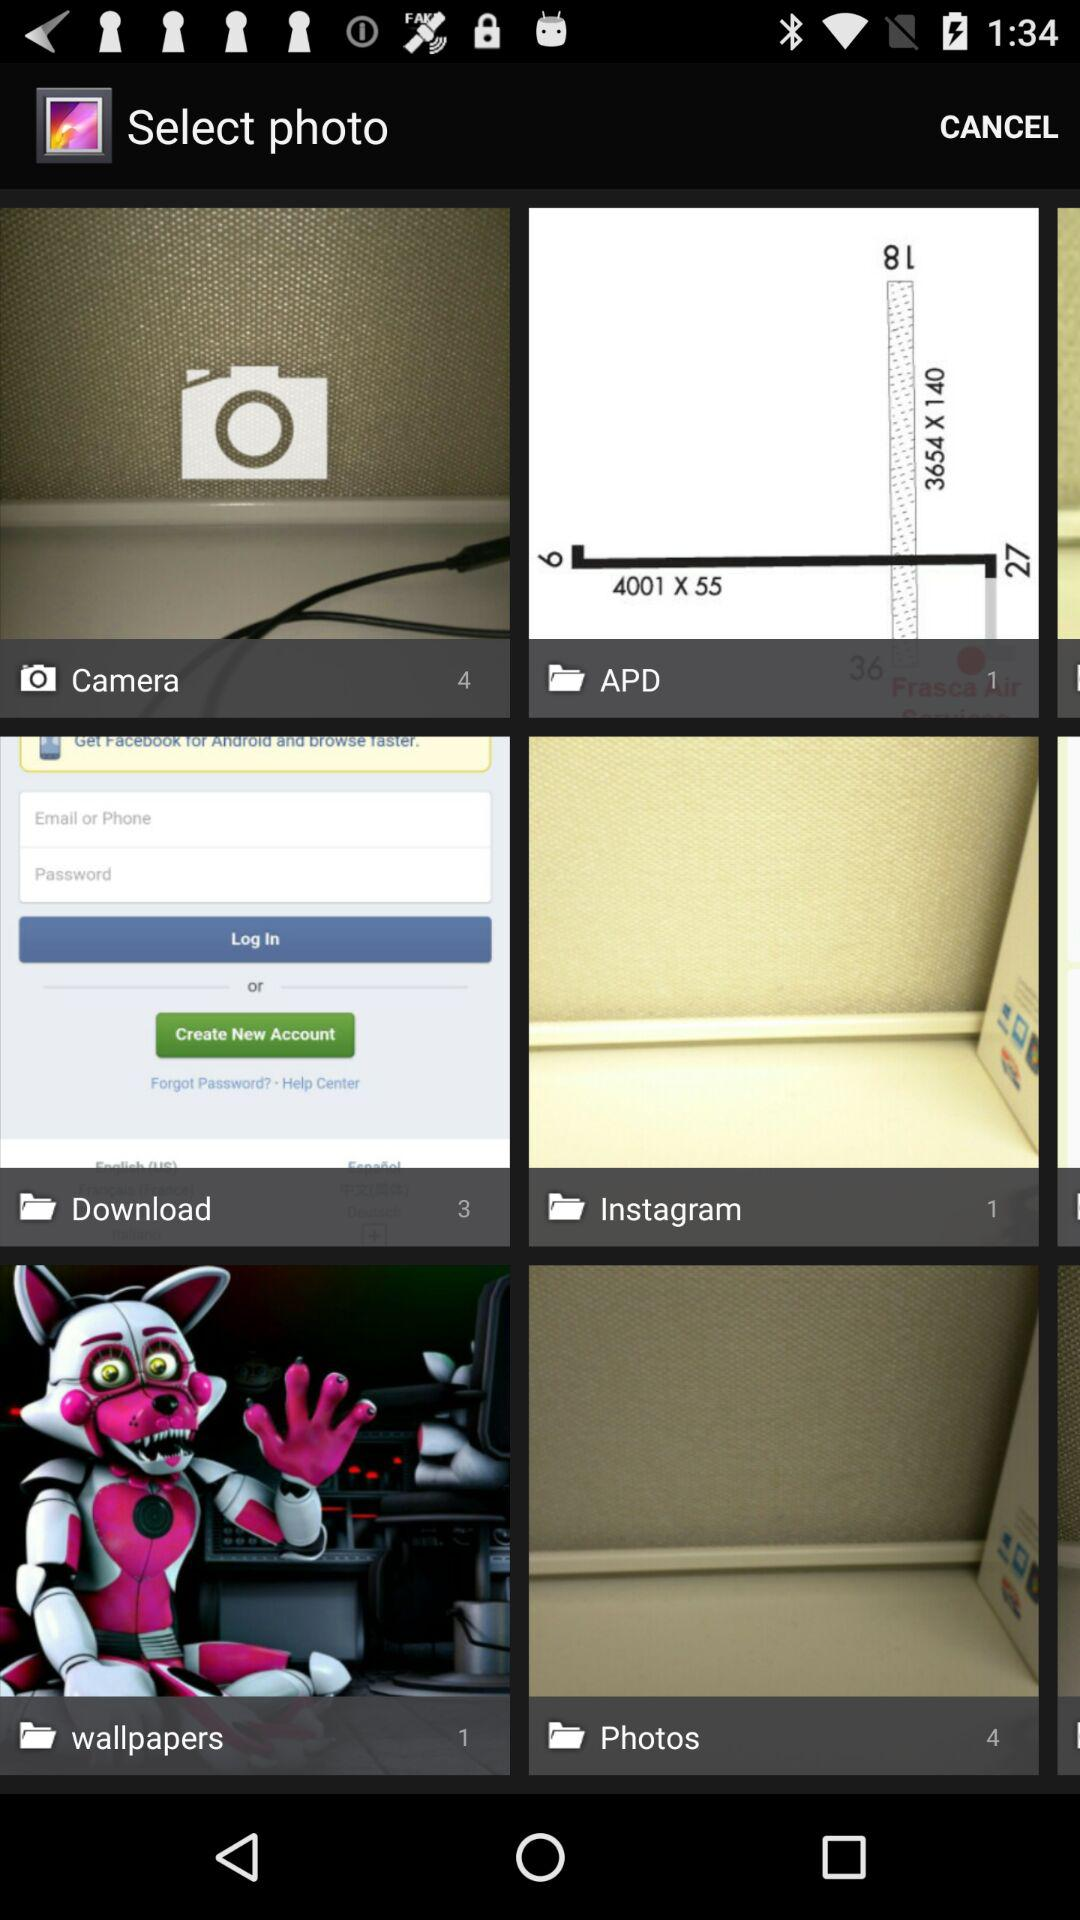What is the number of photos in "Download"? The number of photos in "Download" is 3. 